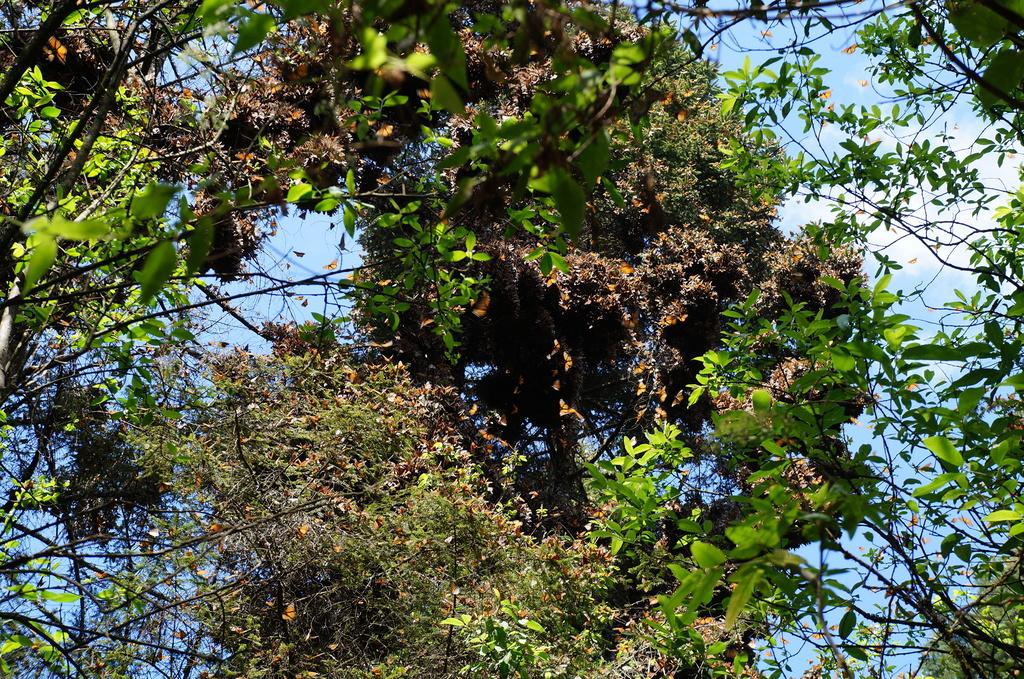What type of vegetation can be seen in the image? There are trees in the image. What part of the natural environment is visible in the image? The sky is visible in the background of the image. What type of order can be seen being placed in the image? There is no order being placed in the image; it only features trees and the sky. 